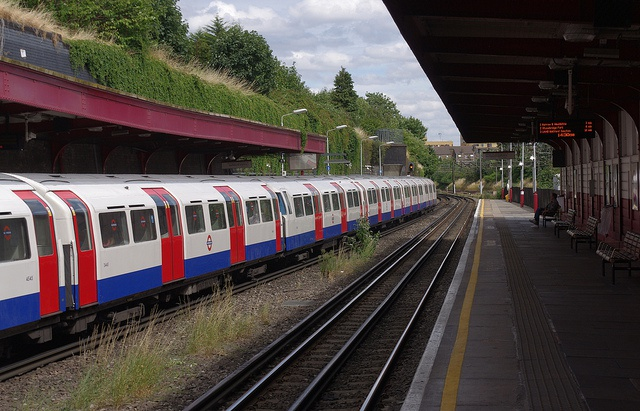Describe the objects in this image and their specific colors. I can see train in tan, darkgray, lightgray, black, and gray tones, bench in tan, black, and gray tones, bench in tan, black, and gray tones, people in black, maroon, and tan tones, and bench in tan, black, and gray tones in this image. 